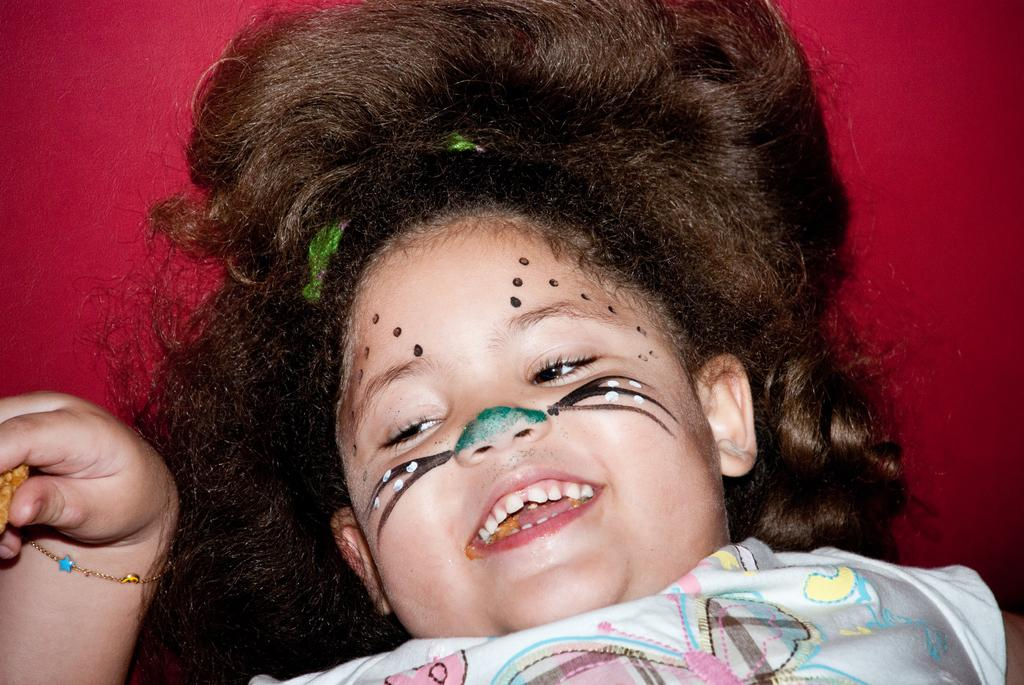What is the girl doing in the image? The girl is lying on the floor in the image. What can be seen in the background of the image? There is a red cloth in the background of the image. How is the girl's face decorated in the image? The girl has colors on her face. What event or occasion might the image be related to? The scene appears to be related to Halloween. What type of sleet can be seen falling in the image? There is no sleet present in the image; it is an indoor scene. 